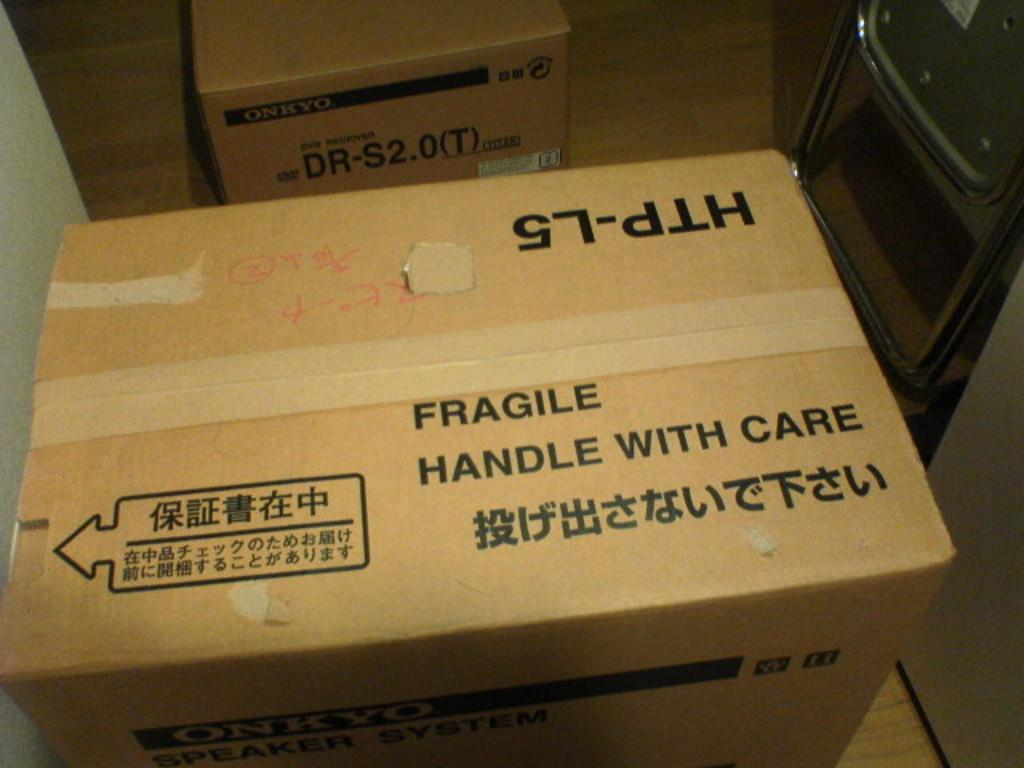<image>
Share a concise interpretation of the image provided. cardboard box with the word fragile written across 